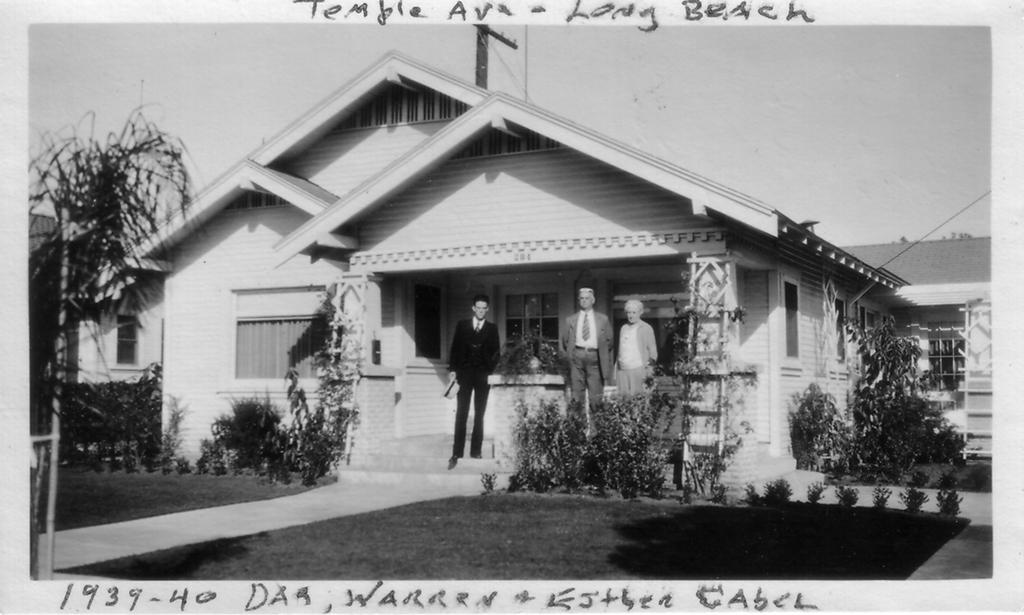What is the color scheme of the image? The image is black and white. What can be seen in the image besides the color scheme? There are people standing in the image, along with grass, plants, a wooden house, trees, and the sky visible in the background. What invention is being demonstrated by the people in the image? There is no invention being demonstrated in the image; it simply shows people standing in a natural environment with a wooden house and vegetation. Can you see any worms crawling on the grass in the image? There are no worms visible in the image; it only shows people, grass, plants, a wooden house, trees, and the sky. 